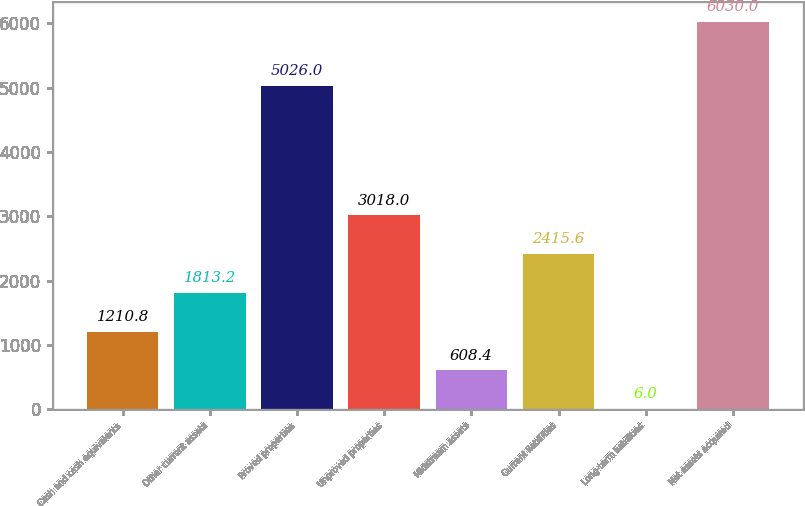Convert chart. <chart><loc_0><loc_0><loc_500><loc_500><bar_chart><fcel>Cash and cash equivalents<fcel>Other current assets<fcel>Proved properties<fcel>Unproved properties<fcel>Midstream assets<fcel>Current liabilities<fcel>Long-term liabilities<fcel>Net assets acquired<nl><fcel>1210.8<fcel>1813.2<fcel>5026<fcel>3018<fcel>608.4<fcel>2415.6<fcel>6<fcel>6030<nl></chart> 